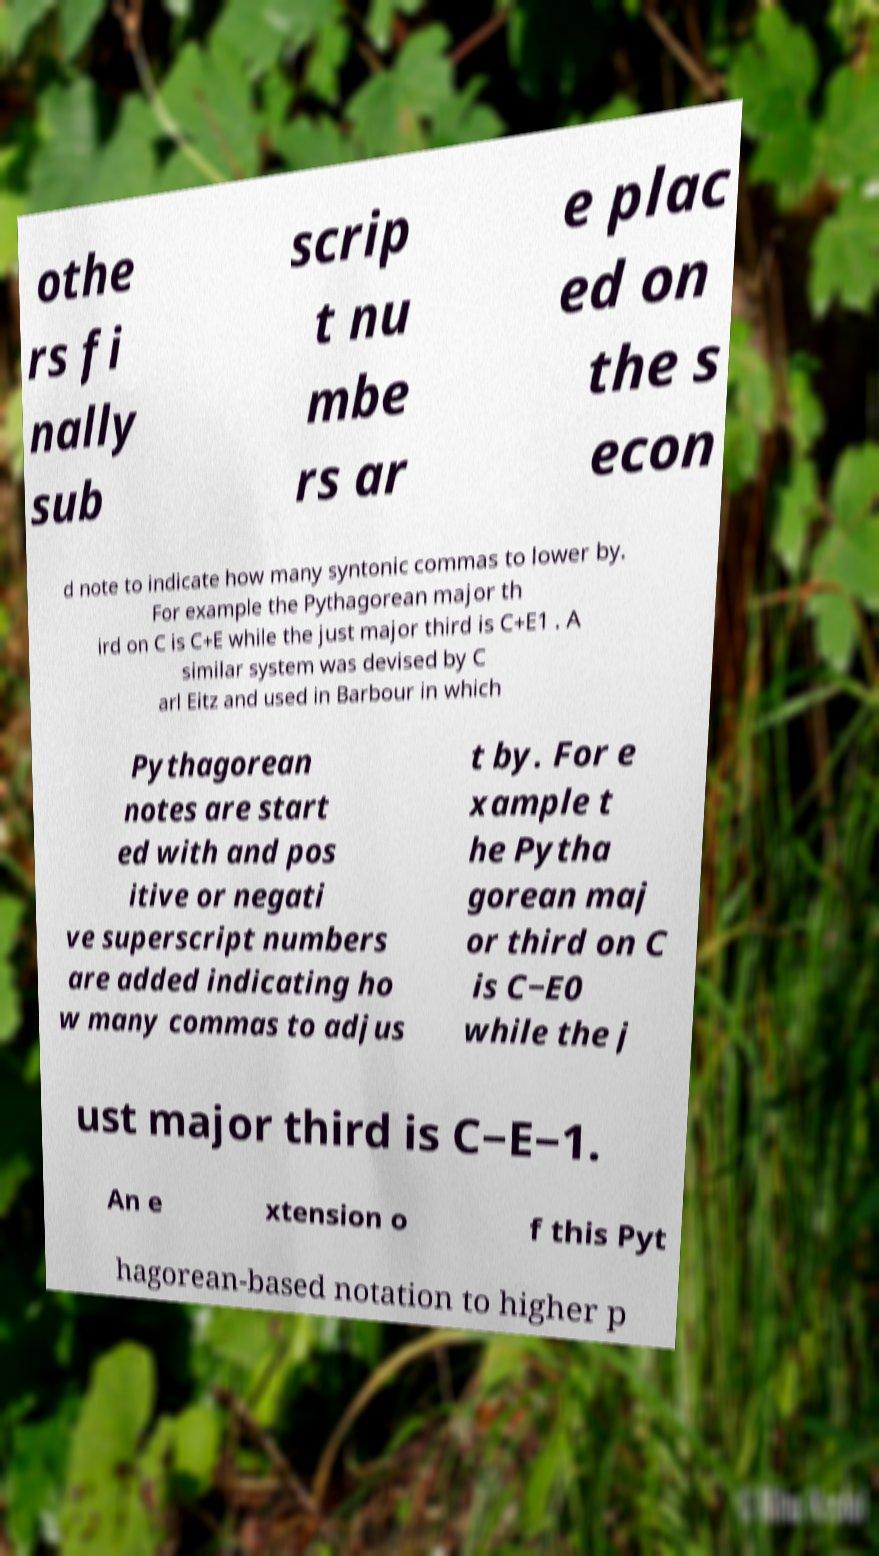There's text embedded in this image that I need extracted. Can you transcribe it verbatim? othe rs fi nally sub scrip t nu mbe rs ar e plac ed on the s econ d note to indicate how many syntonic commas to lower by. For example the Pythagorean major th ird on C is C+E while the just major third is C+E1 . A similar system was devised by C arl Eitz and used in Barbour in which Pythagorean notes are start ed with and pos itive or negati ve superscript numbers are added indicating ho w many commas to adjus t by. For e xample t he Pytha gorean maj or third on C is C−E0 while the j ust major third is C−E−1. An e xtension o f this Pyt hagorean-based notation to higher p 